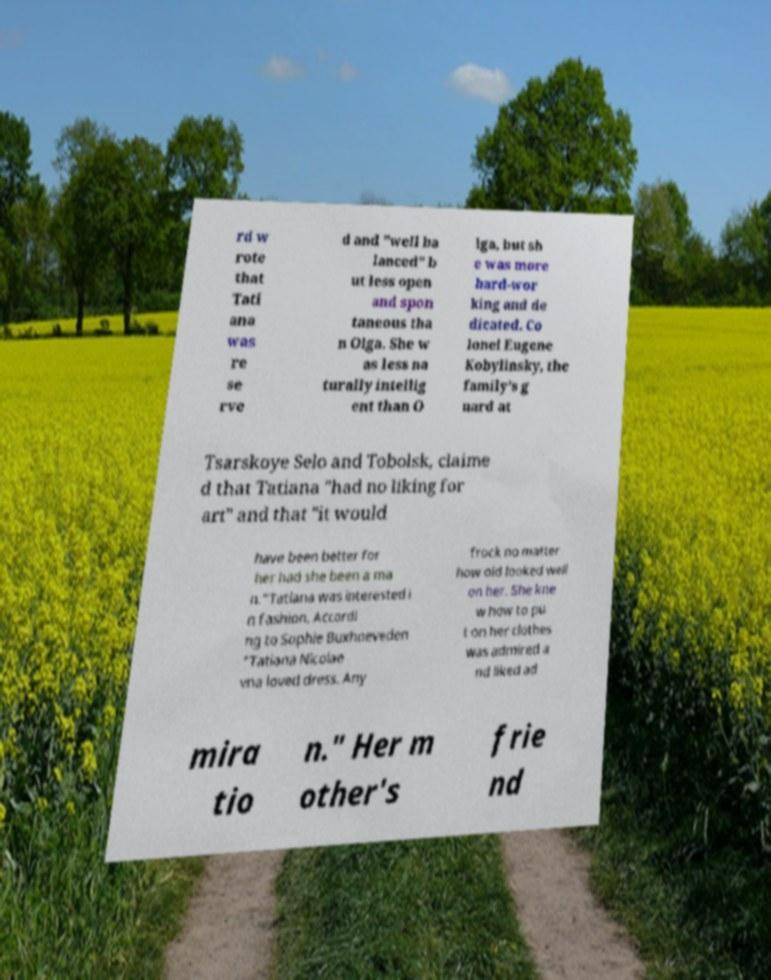There's text embedded in this image that I need extracted. Can you transcribe it verbatim? rd w rote that Tati ana was re se rve d and "well ba lanced" b ut less open and spon taneous tha n Olga. She w as less na turally intellig ent than O lga, but sh e was more hard-wor king and de dicated. Co lonel Eugene Kobylinsky, the family's g uard at Tsarskoye Selo and Tobolsk, claime d that Tatiana "had no liking for art" and that "it would have been better for her had she been a ma n."Tatiana was interested i n fashion. Accordi ng to Sophie Buxhoeveden "Tatiana Nicolae vna loved dress. Any frock no matter how old looked well on her. She kne w how to pu t on her clothes was admired a nd liked ad mira tio n." Her m other's frie nd 